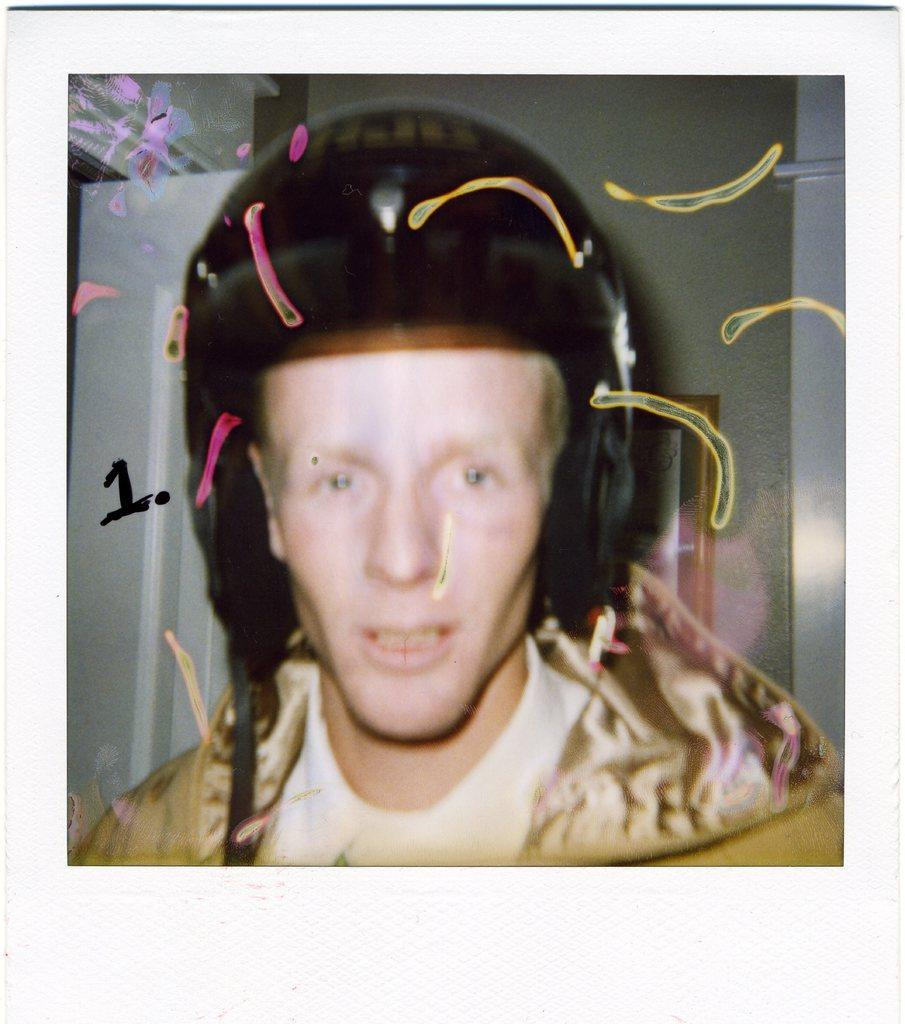What type of object is the main subject of the image? The image is a photo frame. Who is featured in the photo frame? There is a man in the photo frame. What is the man wearing on his head? The man is wearing a black helmet. Can you describe the background of the image? There is a photo frame attached to a wall in the background, and a metal instrument is visible. How many chickens can be seen in the image? There are no chickens present in the image. What color is the eye of the man in the photo frame? The image is a photo, so it is a two-dimensional representation and does not have an eye. 